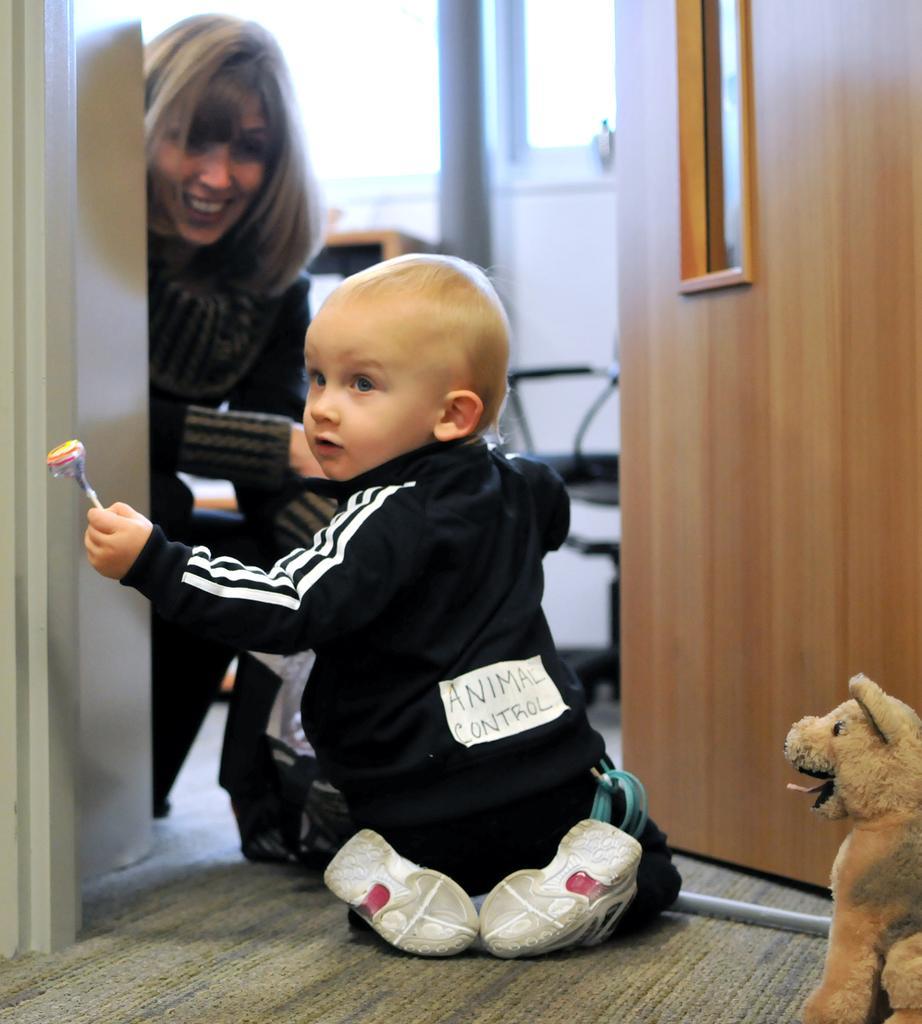Describe this image in one or two sentences. In this picture we can see a small boy wearing black jacket and sitting on the flooring mat. Behind we can see the wooden door and a mother looking to him and smiling. In the background there is a white glass door. 